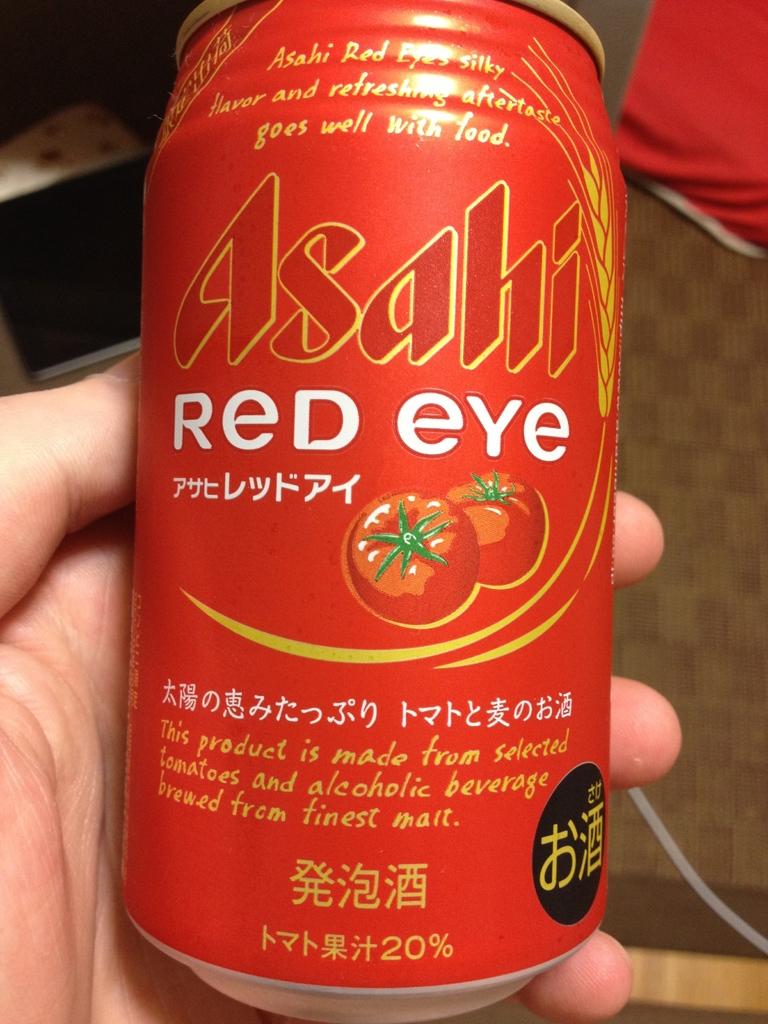With what does this go well?
Your answer should be compact. Food. 